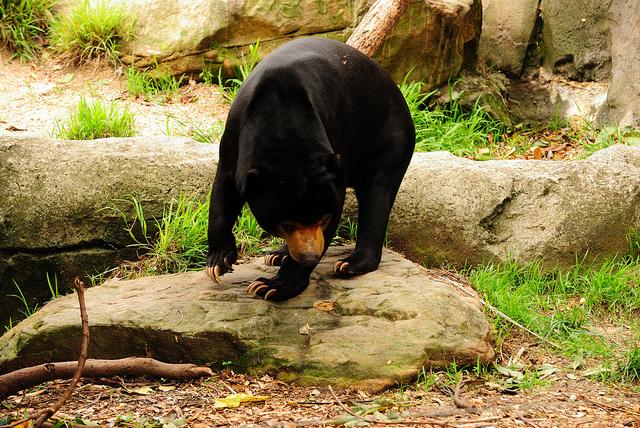Could this be a zoo?
Answer briefly. Yes. Is the bear playing?
Concise answer only. Yes. What animal is this?
Answer briefly. Bear. 